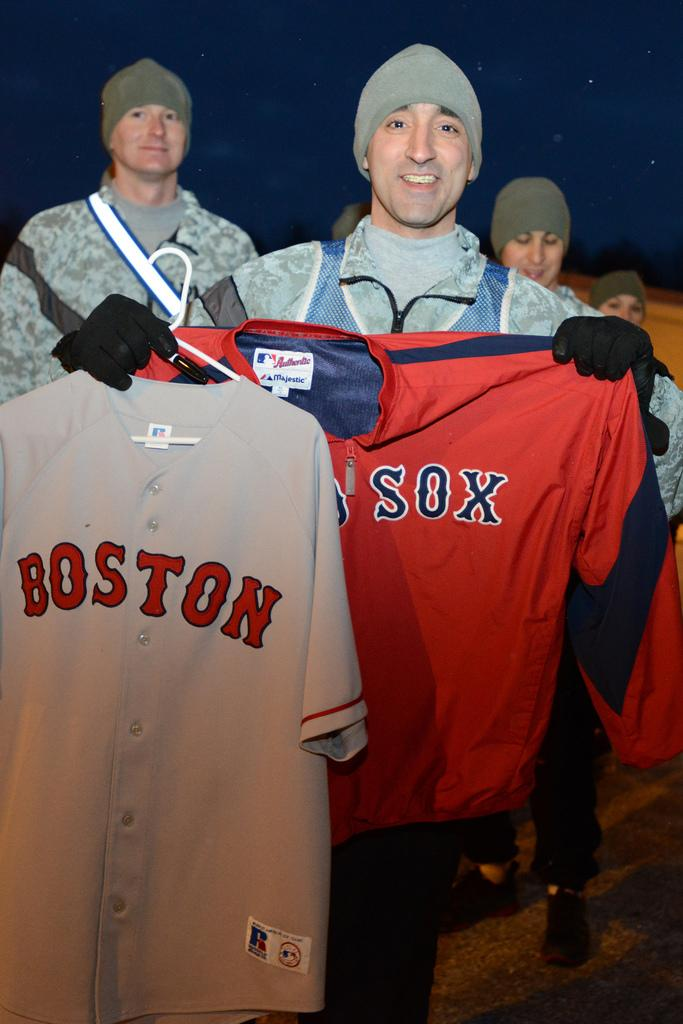<image>
Render a clear and concise summary of the photo. Man holding up a jersey which says Boston on it. 